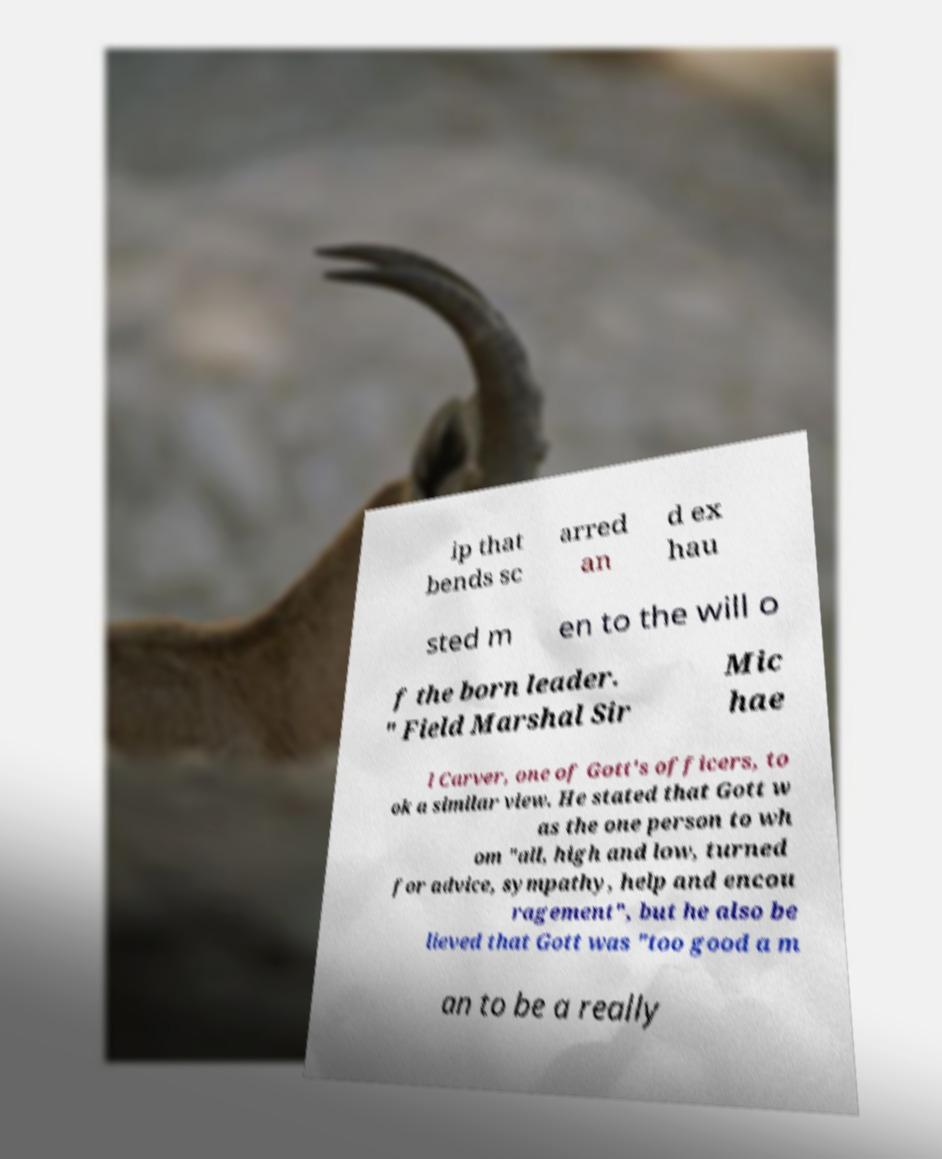For documentation purposes, I need the text within this image transcribed. Could you provide that? ip that bends sc arred an d ex hau sted m en to the will o f the born leader. " Field Marshal Sir Mic hae l Carver, one of Gott's officers, to ok a similar view. He stated that Gott w as the one person to wh om "all, high and low, turned for advice, sympathy, help and encou ragement", but he also be lieved that Gott was "too good a m an to be a really 